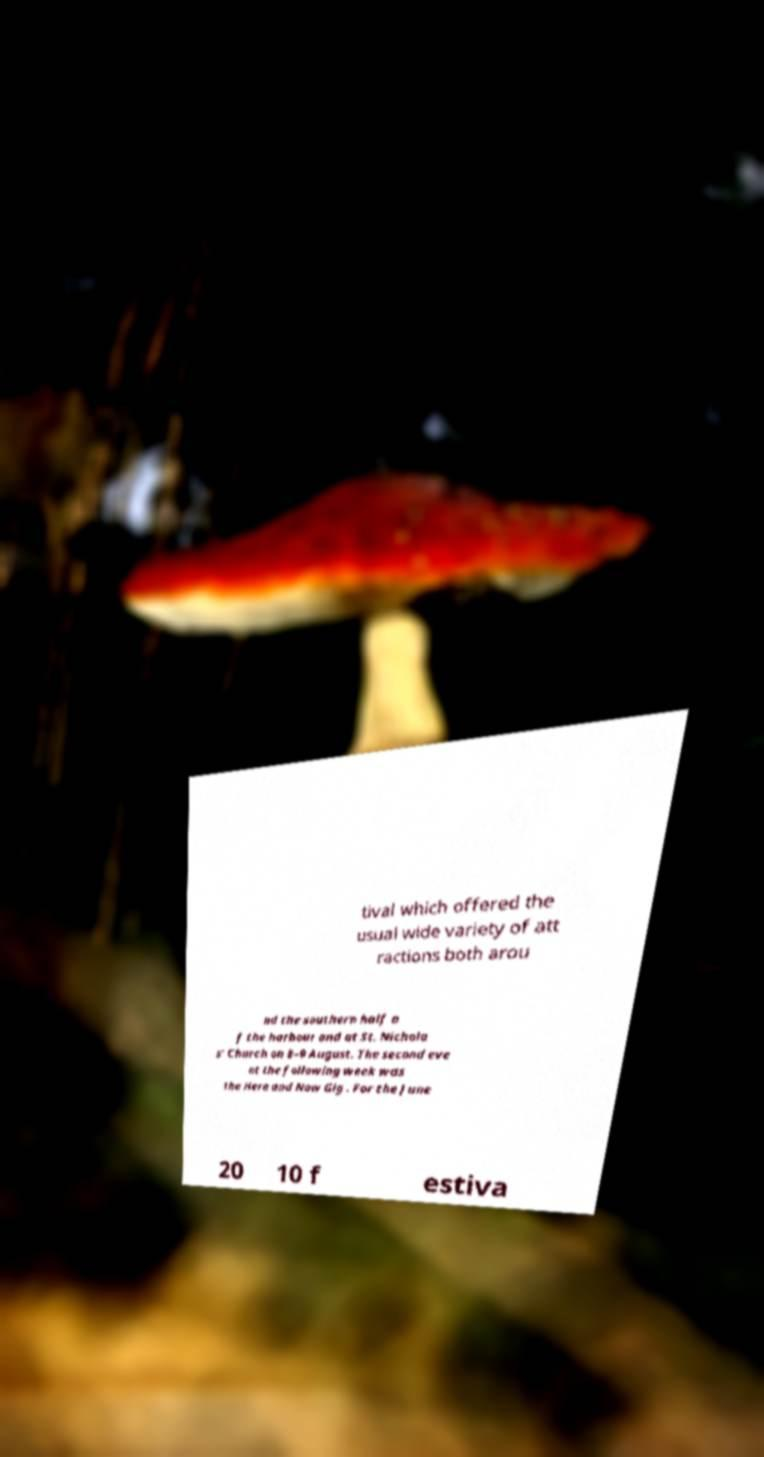Can you read and provide the text displayed in the image?This photo seems to have some interesting text. Can you extract and type it out for me? tival which offered the usual wide variety of att ractions both arou nd the southern half o f the harbour and at St. Nichola s' Church on 8–9 August. The second eve nt the following week was the Here and Now Gig . For the June 20 10 f estiva 